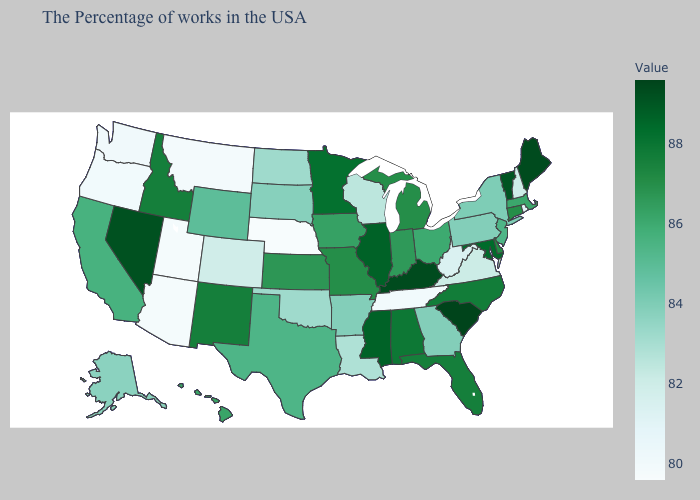Which states have the lowest value in the MidWest?
Write a very short answer. Nebraska. Which states have the lowest value in the MidWest?
Be succinct. Nebraska. Which states have the highest value in the USA?
Quick response, please. South Carolina. Which states have the lowest value in the West?
Give a very brief answer. Utah, Arizona. Does Nebraska have the lowest value in the USA?
Give a very brief answer. Yes. Does Illinois have the highest value in the MidWest?
Concise answer only. Yes. 